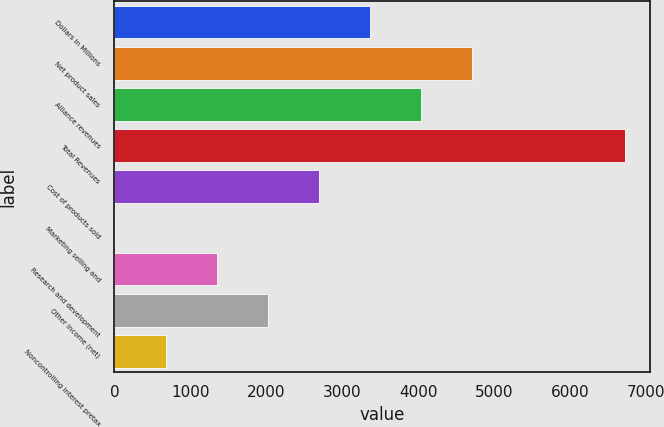Convert chart. <chart><loc_0><loc_0><loc_500><loc_500><bar_chart><fcel>Dollars in Millions<fcel>Net product sales<fcel>Alliance revenues<fcel>Total Revenues<fcel>Cost of products sold<fcel>Marketing selling and<fcel>Research and development<fcel>Other income (net)<fcel>Noncontrolling interest pretax<nl><fcel>3365.5<fcel>4705.7<fcel>4035.6<fcel>6716<fcel>2695.4<fcel>15<fcel>1355.2<fcel>2025.3<fcel>685.1<nl></chart> 